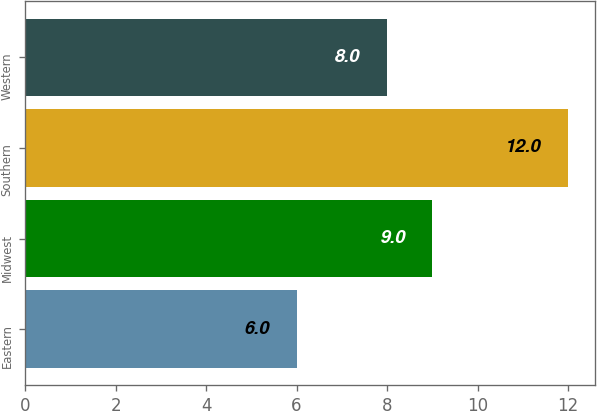<chart> <loc_0><loc_0><loc_500><loc_500><bar_chart><fcel>Eastern<fcel>Midwest<fcel>Southern<fcel>Western<nl><fcel>6<fcel>9<fcel>12<fcel>8<nl></chart> 